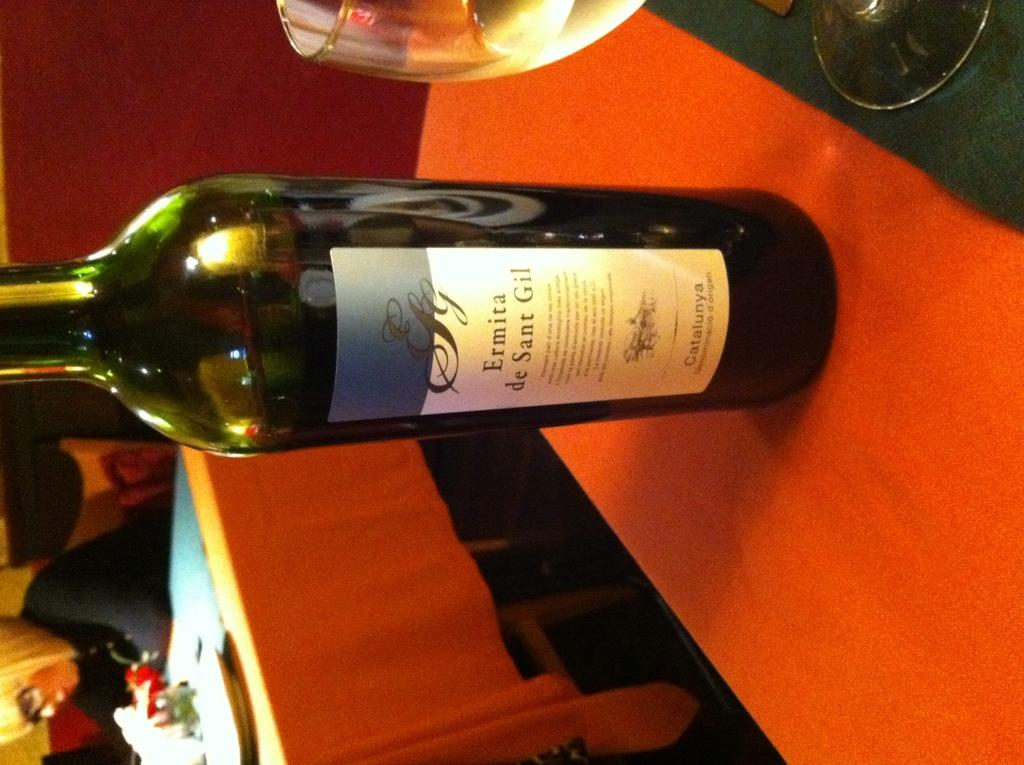<image>
Relay a brief, clear account of the picture shown. A bottle of Ermita wine is on a table. 